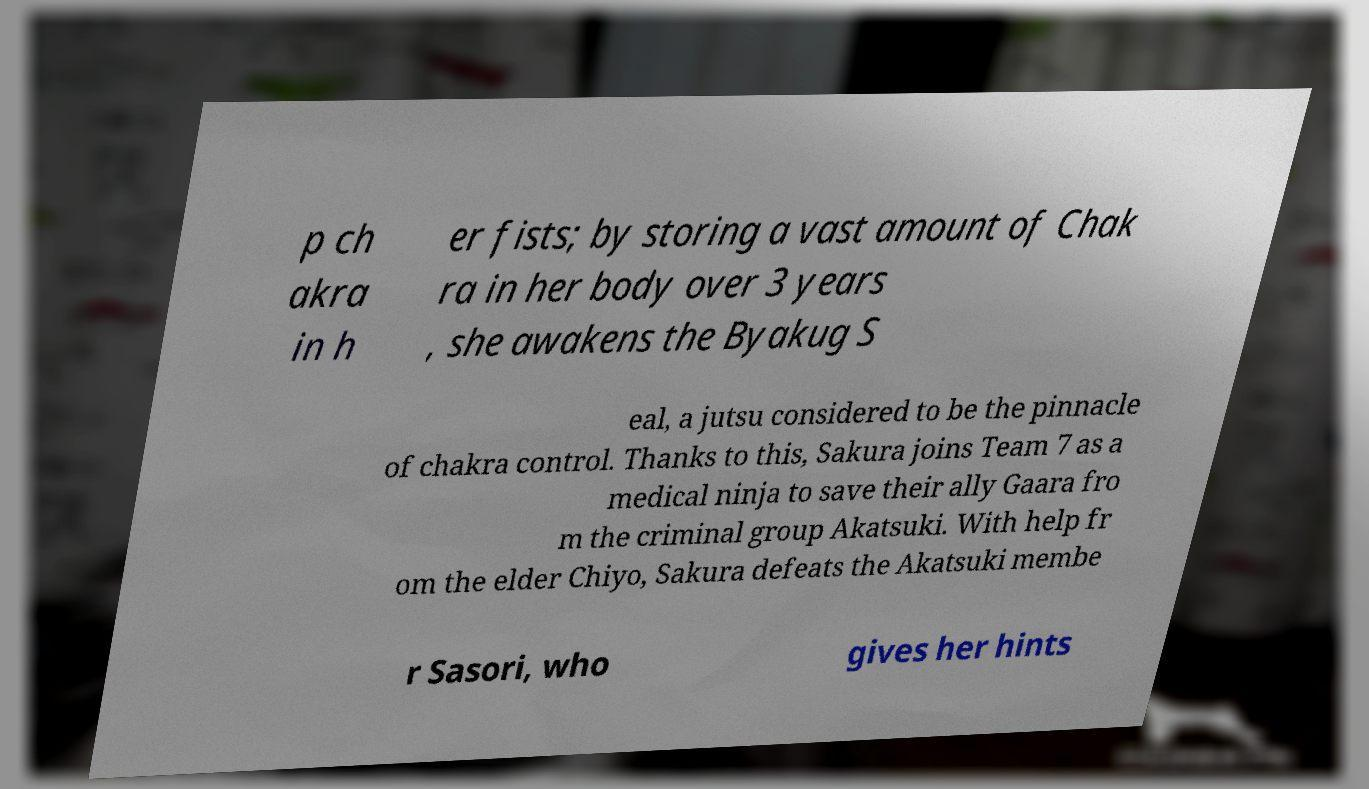Please read and relay the text visible in this image. What does it say? p ch akra in h er fists; by storing a vast amount of Chak ra in her body over 3 years , she awakens the Byakug S eal, a jutsu considered to be the pinnacle of chakra control. Thanks to this, Sakura joins Team 7 as a medical ninja to save their ally Gaara fro m the criminal group Akatsuki. With help fr om the elder Chiyo, Sakura defeats the Akatsuki membe r Sasori, who gives her hints 